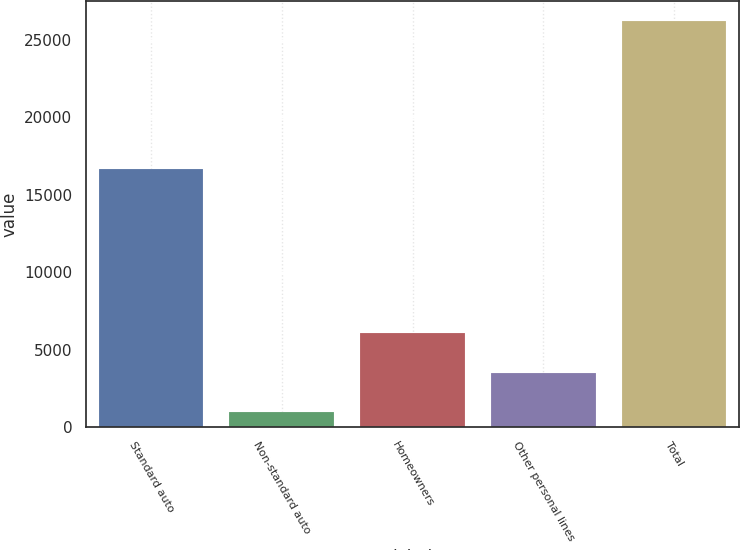Convert chart to OTSL. <chart><loc_0><loc_0><loc_500><loc_500><bar_chart><fcel>Standard auto<fcel>Non-standard auto<fcel>Homeowners<fcel>Other personal lines<fcel>Total<nl><fcel>16642<fcel>966<fcel>6077<fcel>3488.9<fcel>26195<nl></chart> 